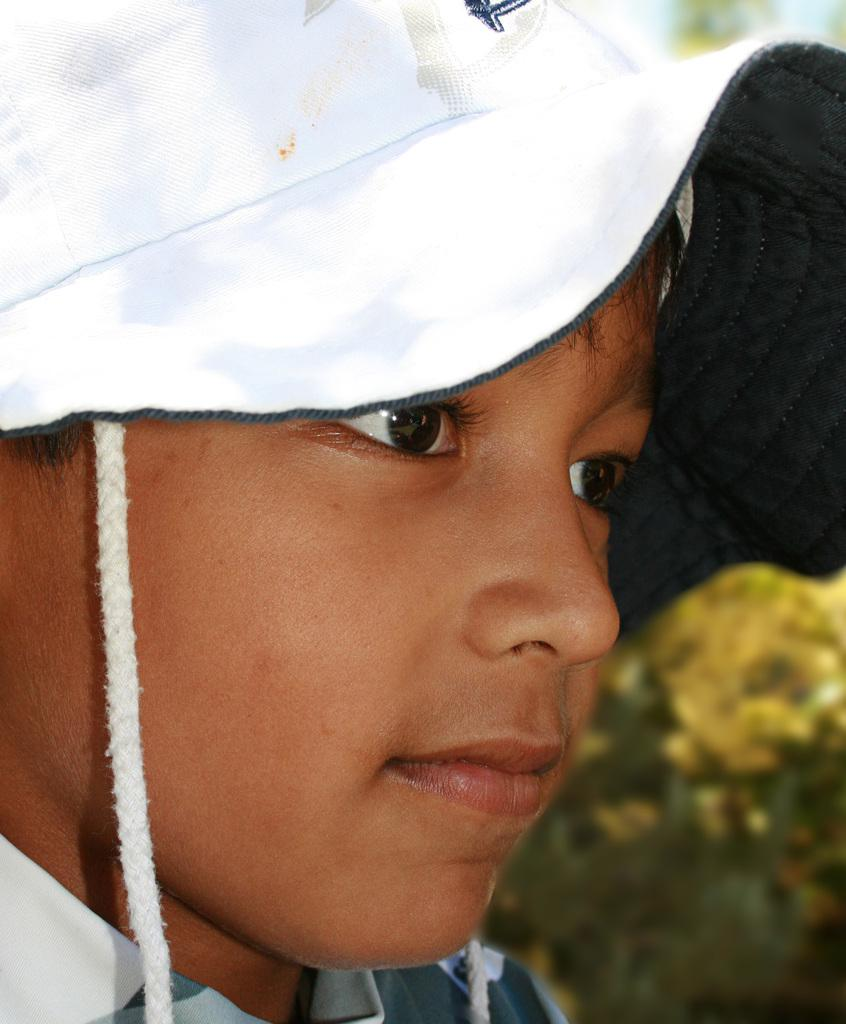What is the main subject of the image? The main subject of the image is a boy's face. What is the boy wearing on his head? The boy is wearing a white cap. What type of hope can be seen in the boy's eyes in the image? There is no indication of hope or any emotions in the boy's eyes in the image. 